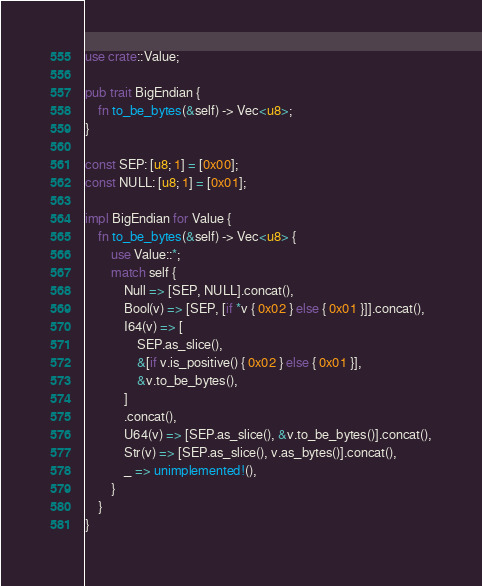<code> <loc_0><loc_0><loc_500><loc_500><_Rust_>use crate::Value;

pub trait BigEndian {
	fn to_be_bytes(&self) -> Vec<u8>;
}

const SEP: [u8; 1] = [0x00];
const NULL: [u8; 1] = [0x01];

impl BigEndian for Value {
	fn to_be_bytes(&self) -> Vec<u8> {
		use Value::*;
		match self {
			Null => [SEP, NULL].concat(),
			Bool(v) => [SEP, [if *v { 0x02 } else { 0x01 }]].concat(),
			I64(v) => [
				SEP.as_slice(),
				&[if v.is_positive() { 0x02 } else { 0x01 }],
				&v.to_be_bytes(),
			]
			.concat(),
			U64(v) => [SEP.as_slice(), &v.to_be_bytes()].concat(),
			Str(v) => [SEP.as_slice(), v.as_bytes()].concat(),
			_ => unimplemented!(),
		}
	}
}
</code> 